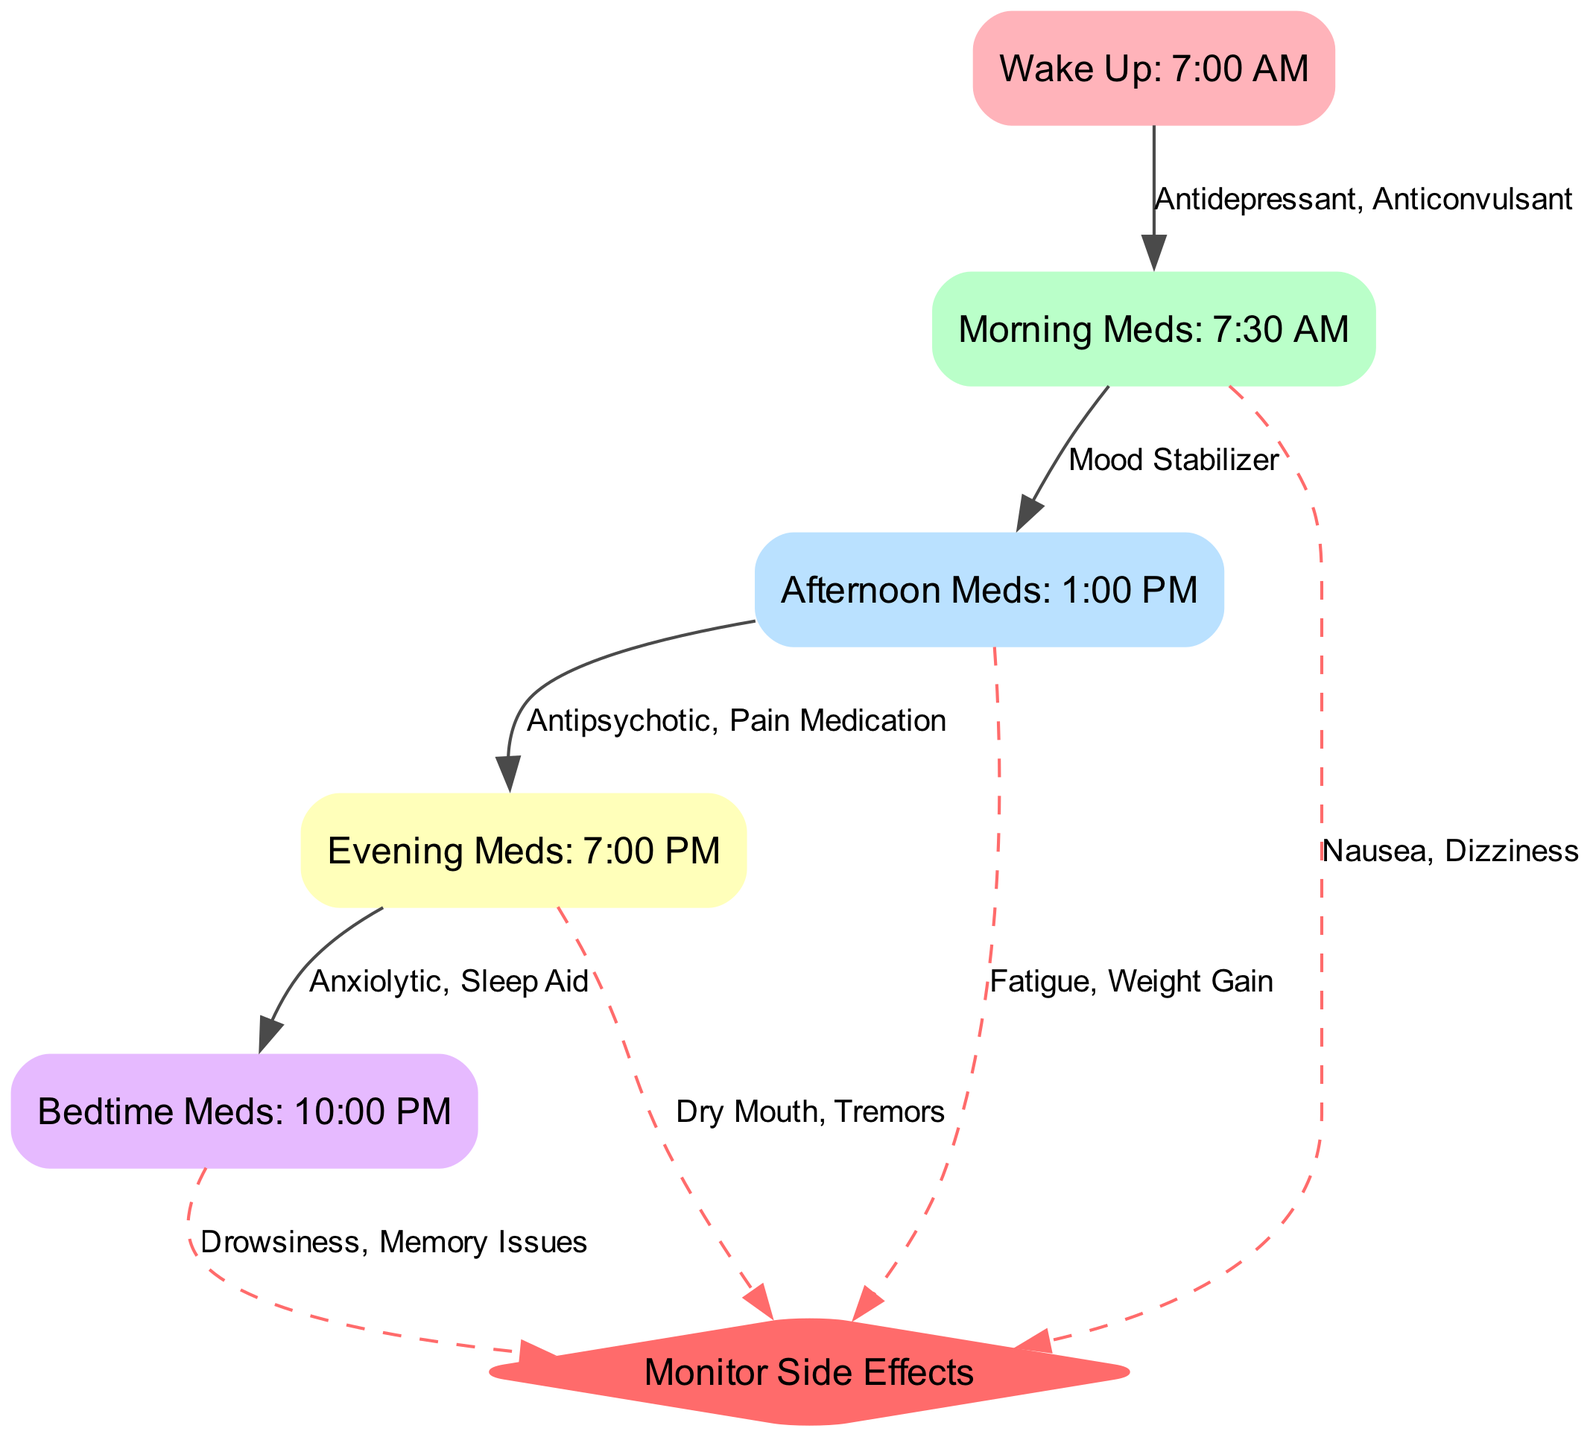What time are the morning medications scheduled? The diagram specifies the time for the morning medications as 7:30 AM. This is indicated by the node labeled "Morning Meds" that relates to the "Wake Up" node.
Answer: 7:30 AM How many medications are taken during the afternoon? The diagram indicates that one medication, a mood stabilizer, is taken during the afternoon at 1:00 PM. This is inferred from the edge that connects "Morning Meds" to "Afternoon Meds".
Answer: One What side effects are associated with the evening medications? The diagram lists the side effects for the evening medications as "Dry Mouth, Tremors". This is shown on the edge connecting the "Evening Meds" node to the "Monitor Side Effects" node.
Answer: Dry Mouth, Tremors What medication is taken just before bedtime? According to the diagram, the medication taken just before bedtime is an anxiolytic and sleep aid at 10:00 PM. This is derived from the node labeled "Bedtime Meds".
Answer: Anxiolytic, Sleep Aid Is there a medication taken in the morning that has side effects? If so, what are they? Yes, the morning medications, which include an antidepressant and anticonvulsant, have side effects noted as "Nausea, Dizziness". This information is found on the edge leading to the "Monitor Side Effects" node from "Morning Meds".
Answer: Nausea, Dizziness What is the connection between afternoon medications and side effects? The afternoon medications lead to their own side effects, specifically "Fatigue, Weight Gain". This is shown by the edge that connects "Afternoon Meds" to the "Monitor Side Effects" node.
Answer: Fatigue, Weight Gain Which two medications are scheduled after the morning medications and before bedtime? The medications scheduled after the morning medications are the afternoon meds (a mood stabilizer) and the evening meds (antipsychotic, pain medication), leading up to the bedtime meds. This can be traced from the "Morning Meds" to the "Evening Meds" and then to the "Bedtime Meds" in sequential order.
Answer: Afternoon Meds, Evening Meds How many total medications are scheduled throughout the day? There are a total of five medications scheduled as represented by the nodes from "Morning Meds" through "Bedtime Meds". Each node corresponds to a medication intake time.
Answer: Five Which node indicates the monitoring of side effects? The node that indicates the monitoring of side effects is labeled "Monitor Side Effects". It is distinctly shaped as a diamond in the diagram and is positioned at the end of the medication intake flow.
Answer: Monitor Side Effects 